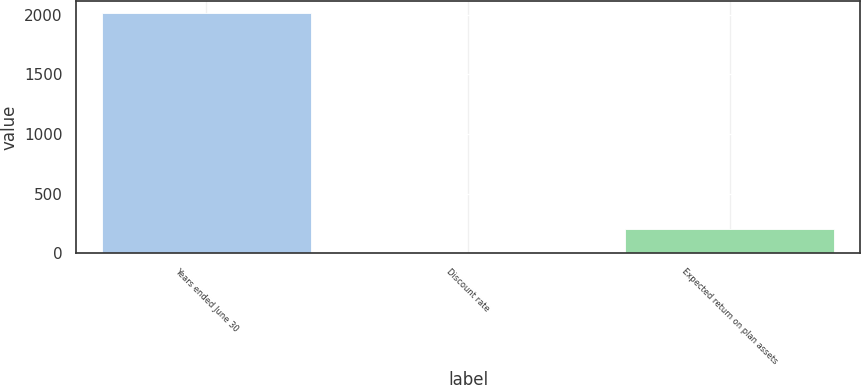Convert chart. <chart><loc_0><loc_0><loc_500><loc_500><bar_chart><fcel>Years ended June 30<fcel>Discount rate<fcel>Expected return on plan assets<nl><fcel>2012<fcel>4.2<fcel>204.98<nl></chart> 